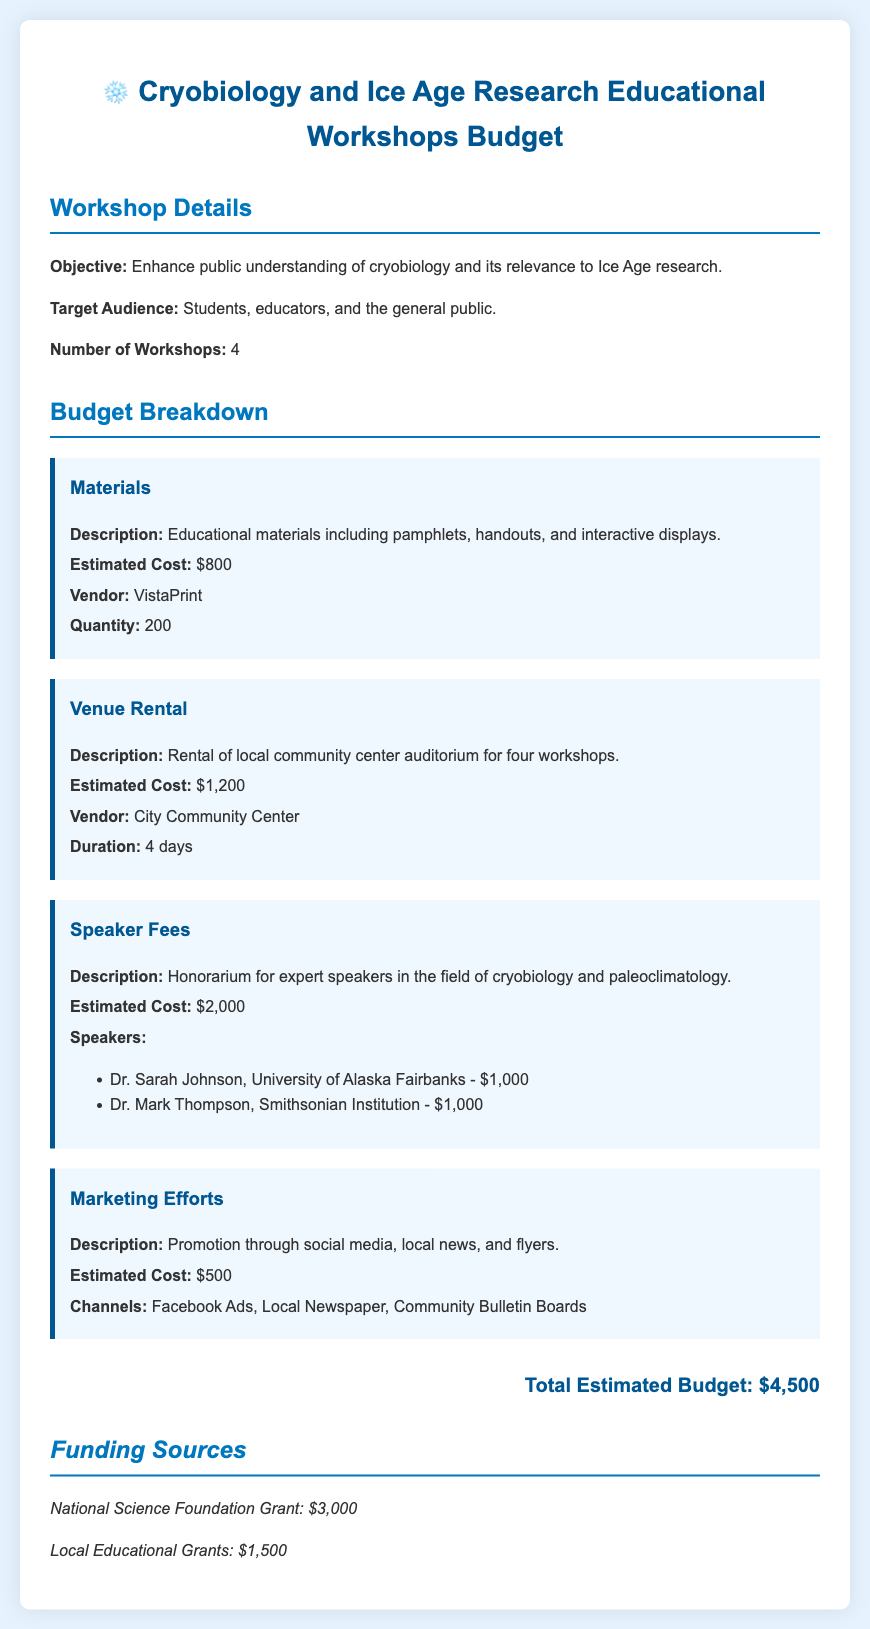What is the total estimated budget? The total estimated budget is listed at the end of the budget breakdown section, which sums all costs for materials, venue rental, speaker fees, and marketing efforts.
Answer: $4,500 How many workshops are being planned? The document states that there are 4 workshops planned in the workshop details section.
Answer: 4 What is the estimated cost for the speaker fees? The estimated cost for speaker fees is provided in the budget breakdown and is a component of the total budget.
Answer: $2,000 Who is one of the speakers from the Smithsonian Institution? The document lists Dr. Mark Thompson as a speaker from the Smithsonian Institution in the speaker fees section.
Answer: Dr. Mark Thompson What is the estimated cost for marketing efforts? The cost of marketing efforts is explicitly stated in the budget breakdown section.
Answer: $500 What vendor provides educational materials? The vendor for educational materials is mentioned in the budget item for materials.
Answer: VistaPrint How long will the venue be rented for? The duration of the venue rental is specified in the venue rental budget item.
Answer: 4 days What is one funding source mentioned in the document? The document lists funding sources including a National Science Foundation Grant and local educational grants in the funding sources section.
Answer: National Science Foundation Grant 